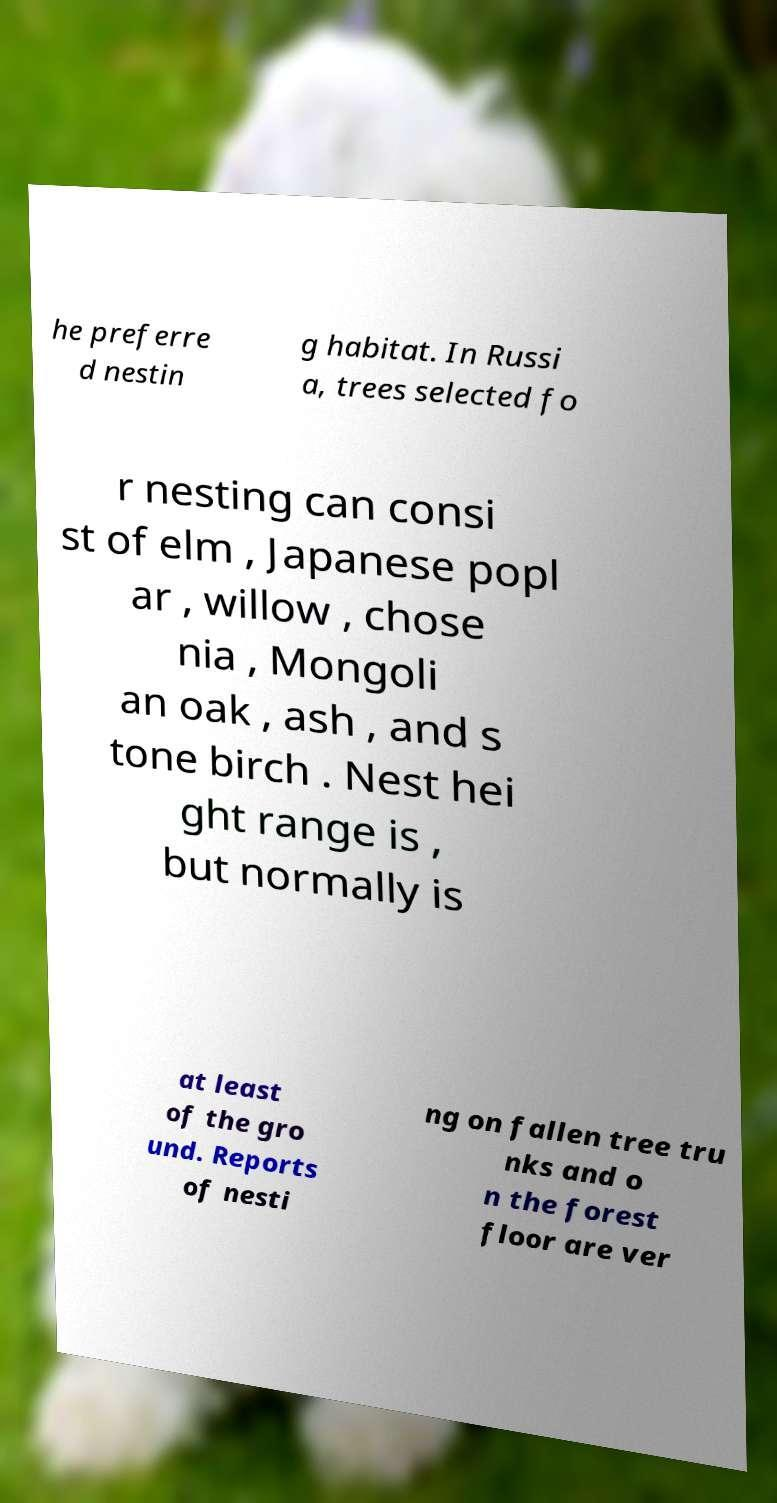For documentation purposes, I need the text within this image transcribed. Could you provide that? he preferre d nestin g habitat. In Russi a, trees selected fo r nesting can consi st of elm , Japanese popl ar , willow , chose nia , Mongoli an oak , ash , and s tone birch . Nest hei ght range is , but normally is at least of the gro und. Reports of nesti ng on fallen tree tru nks and o n the forest floor are ver 